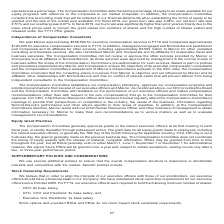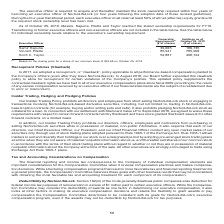According to Nortonlifelock's financial document, What is the ownership requirement based on? the closing price for a share of our common stock of $22.69 on October 25, 2019. The document states: "(1) Based on the closing price for a share of our common stock of $22.69 on October 25, 2019...." Also, What is the minimum number of shares needed by a CEO? According to the financial document, 6x base salary. The relevant text states: "• CEO: 6x base salary;..." Also, What is the minimum number of shares needed by a Executive Vice President? According to the financial document, 2x base salary. The relevant text states: "• Executive Vice Presidents: 2x base salary...." Also, can you calculate: What is the total summed ownership requirement for the Executive officers? Based on the calculation: 39,665+85,941+52,887, the result is 178493. This is based on the information: "incent Pilette . 85,941 785,906 Scott C. Taylor . 52,887 408,724 Samir Kapuria . 39,665 186,735 Vincent Pilette . 85,941 785,906 Scott C. Taylor . 52,887 408,724 Samir Kapuria . 39,665 186,735 Vincent..." The key data points involved are: 39,665, 52,887, 85,941. Also, can you calculate: What is the value of Samir Kapuria's shares as of October 25, 2019? Based on the calculation: 186,735*22.69, the result is 4237017.15. This is based on the information: "Samir Kapuria . 39,665 186,735 Vincent Pilette . 85,941 785,906 Scott C. Taylor . 52,887 408,724 closing price for a share of our common stock of $22.69 on October 25, 2019...." The key data points involved are: 186,735, 22.69. Also, can you calculate: What is the value of Vincent Pilette's shares as of October 25, 2019? Based on the calculation: 785,906*22.69, the result is 17832207.14. This is based on the information: "Kapuria . 39,665 186,735 Vincent Pilette . 85,941 785,906 Scott C. Taylor . 52,887 408,724 closing price for a share of our common stock of $22.69 on October 25, 2019...." The key data points involved are: 22.69, 785,906. 